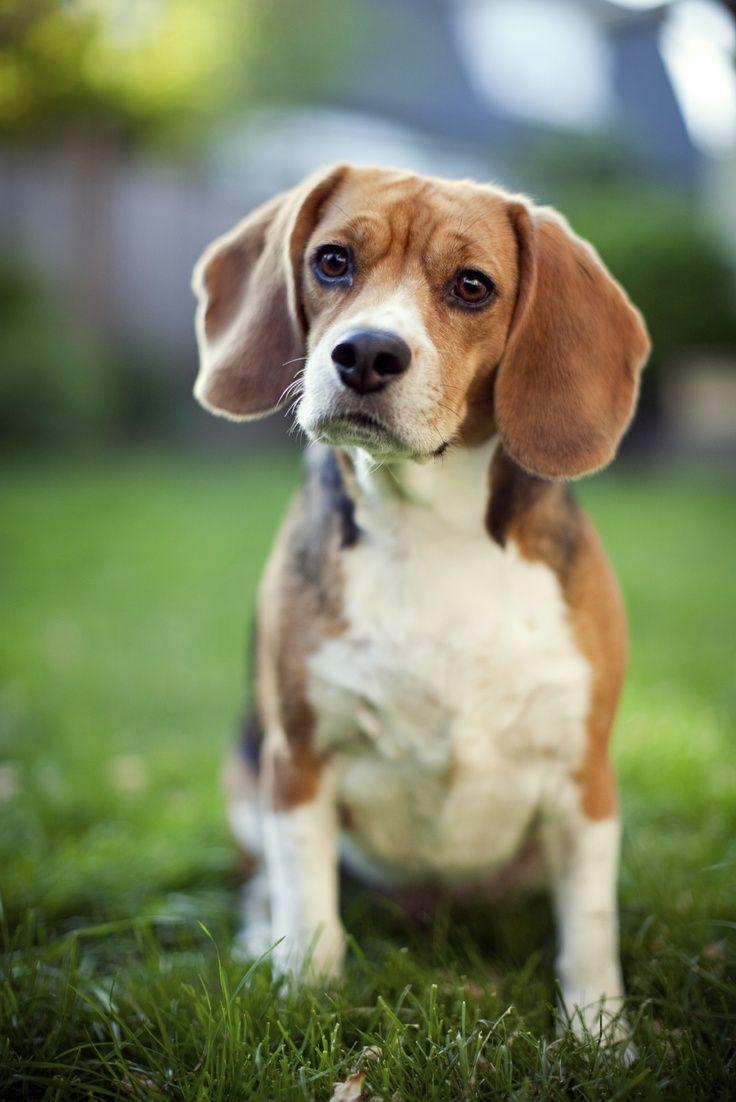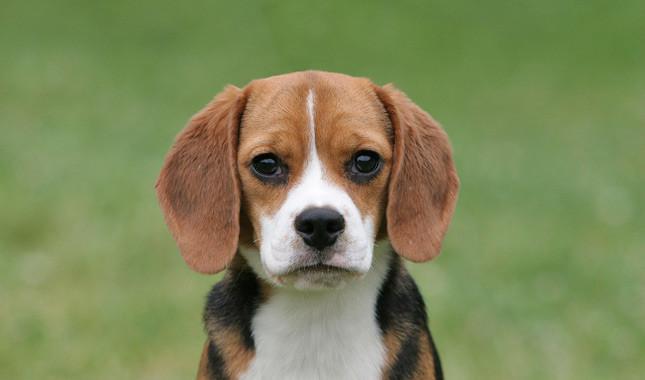The first image is the image on the left, the second image is the image on the right. Evaluate the accuracy of this statement regarding the images: "At least one dog wears something around his neck.". Is it true? Answer yes or no. No. 